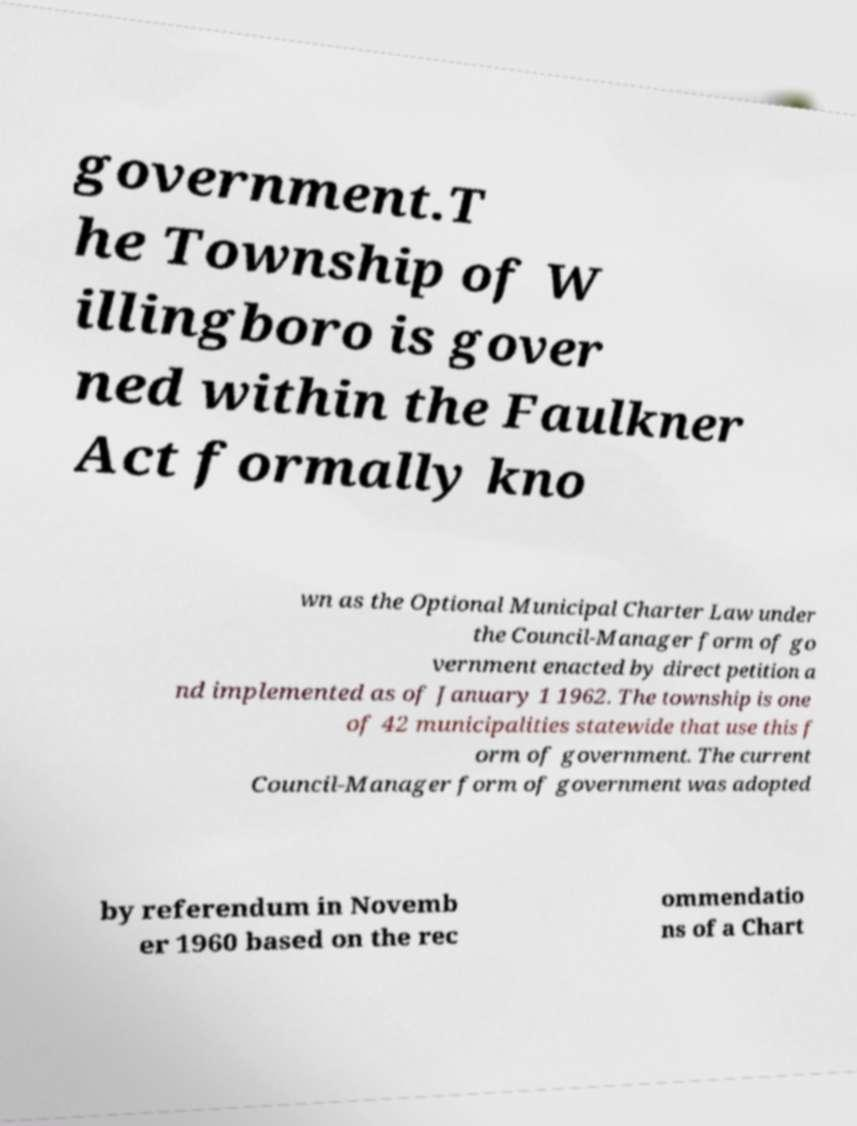What messages or text are displayed in this image? I need them in a readable, typed format. government.T he Township of W illingboro is gover ned within the Faulkner Act formally kno wn as the Optional Municipal Charter Law under the Council-Manager form of go vernment enacted by direct petition a nd implemented as of January 1 1962. The township is one of 42 municipalities statewide that use this f orm of government. The current Council-Manager form of government was adopted by referendum in Novemb er 1960 based on the rec ommendatio ns of a Chart 